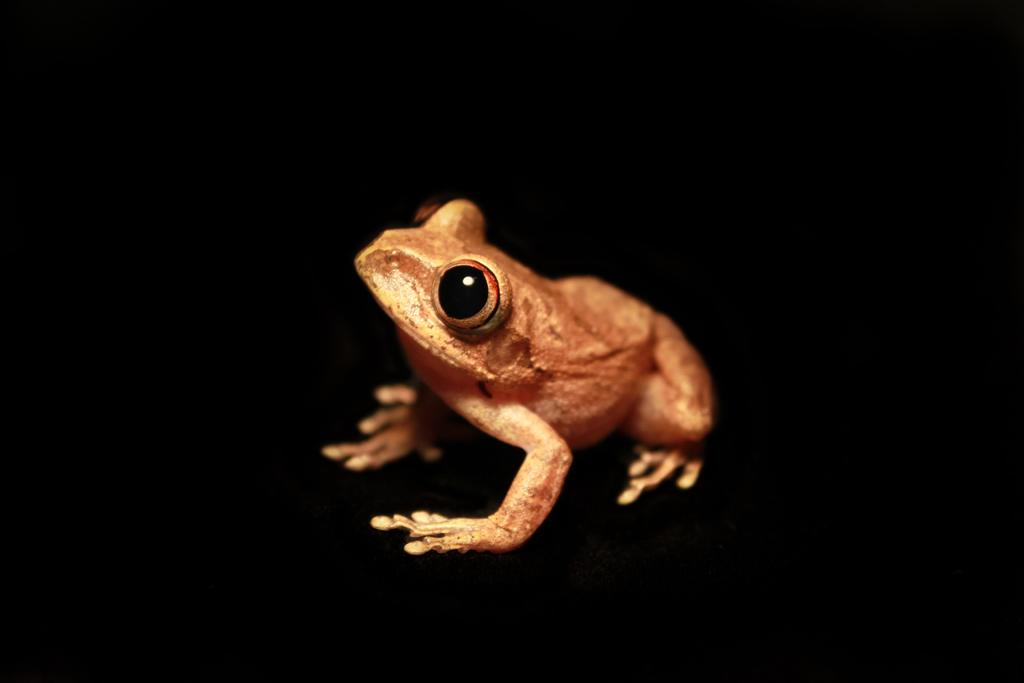What type of animal is in the image? There is a frog in the image. What color is the frog? The frog is brown in color. What color is the background of the image? The background of the image is black. How many fowls are present in the image? There are no fowls present in the image; it features a brown frog against a black background. Can you tell me the number of bats in the image? There are no bats present in the image; it features a brown frog against a black background. 